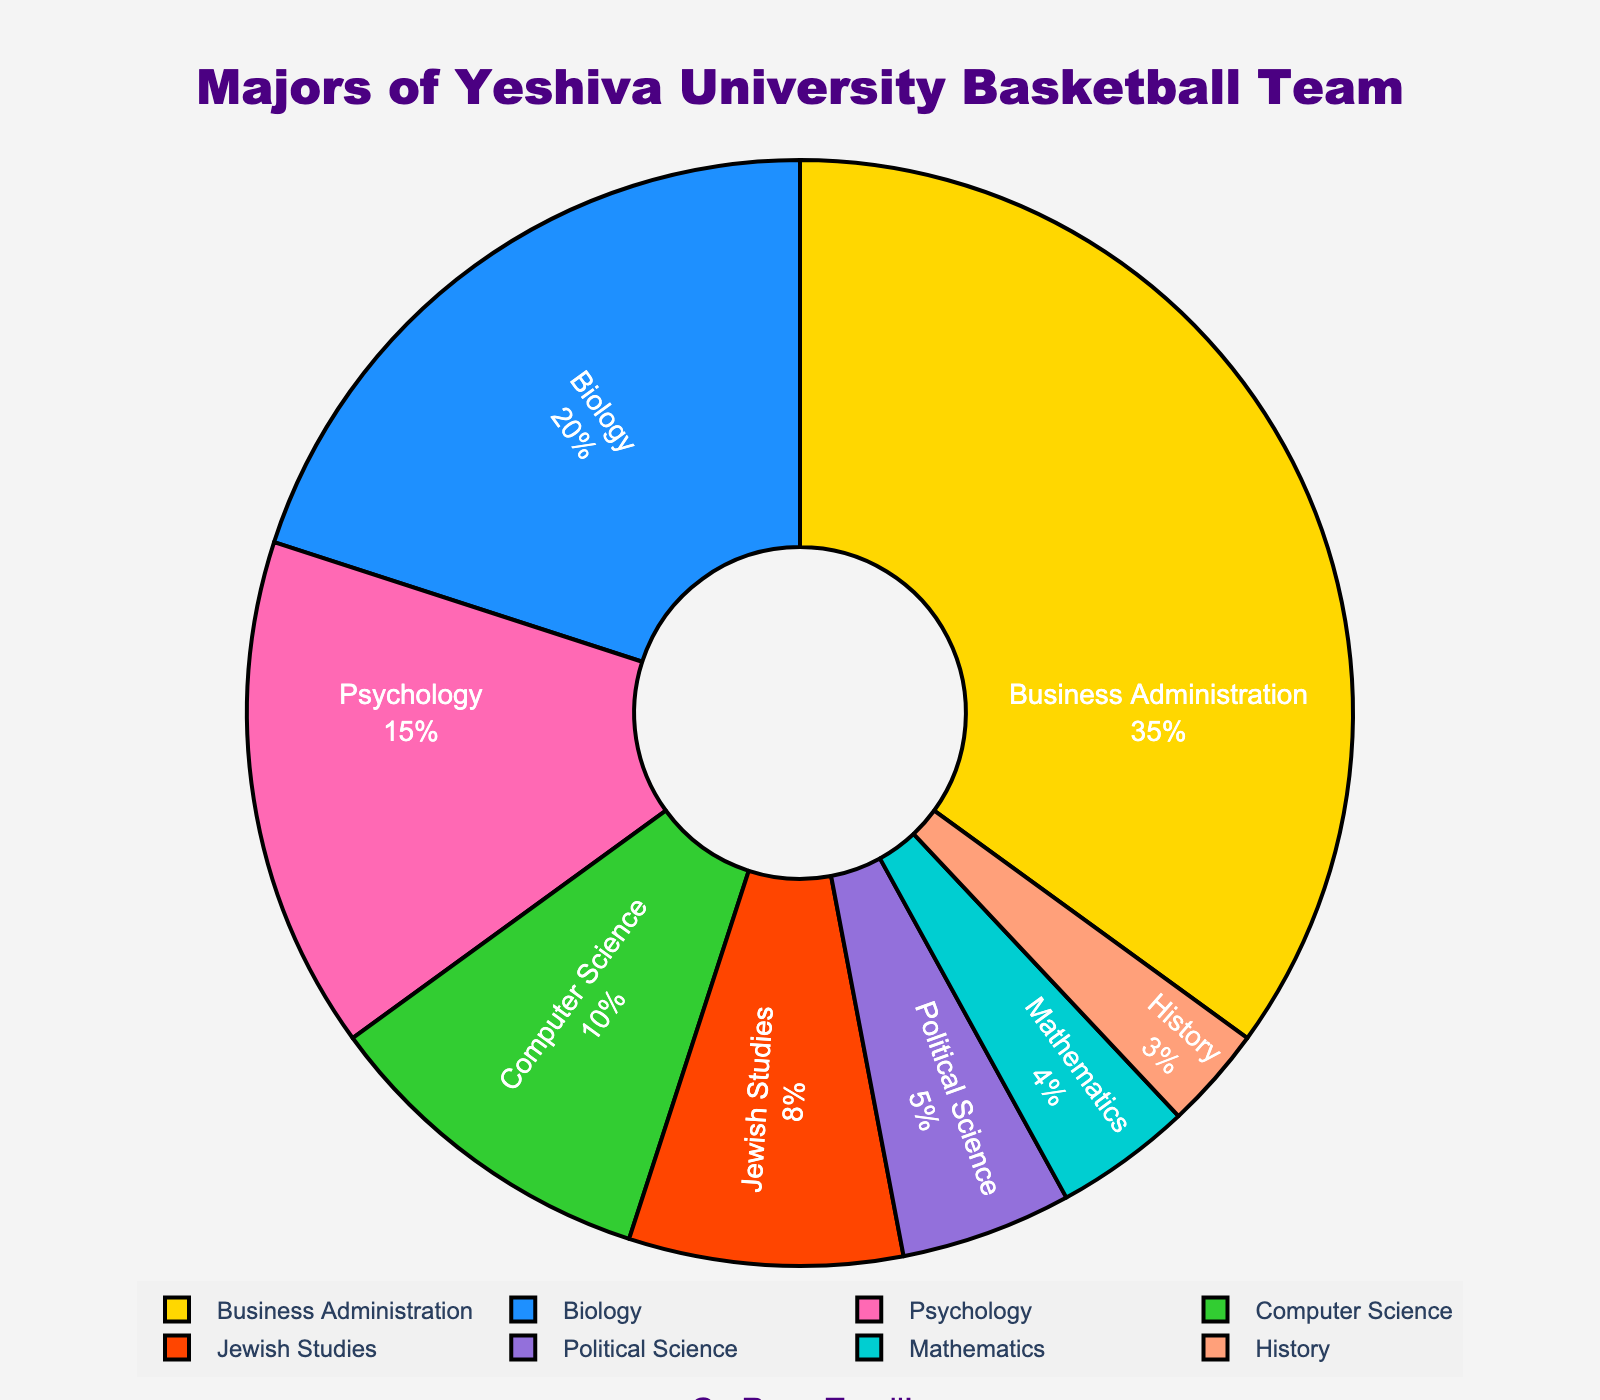what is the most popular major chosen by the basketball team members? The figure shows the percentage breakdown of each major. The major with the largest percentage is the most popular. In this case, it's Business Administration with 35%.
Answer: Business Administration What is the combined percentage of students majoring in Psychology and Political Science? To find the combined percentage, add the percentages for Psychology (15%) and Political Science (5%). 15 + 5 = 20.
Answer: 20% Which major has a lower percentage, Jewish Studies or Mathematics? The figure depicts Jewish Studies at 8% and Mathematics at 4%. By comparing these percentages, Mathematics has a lower percentage than Jewish Studies.
Answer: Mathematics What is the total percentage of students majoring in STEM fields (Biology, Computer Science, and Mathematics)? Add the percentages for Biology (20%), Computer Science (10%), and Mathematics (4%). The sum is 20 + 10 + 4 = 34.
Answer: 34% Estimate the difference in percentage between Business Administration and Biology majors. Subtract the percentage of Biology majors (20%) from Business Administration majors (35%). 35 - 20 = 15.
Answer: 15% Rank the top three majors by their percentage. The figure shows the percentages for all majors. The top three are Business Administration (35%), Biology (20%), and Psychology (15%) in descending order.
Answer: Business Administration, Biology, Psychology Are more students majoring in Computer Science or Jewish Studies? The figure shows Computer Science at 10% and Jewish Studies at 8%. Computer Science has a higher percentage than Jewish Studies.
Answer: Computer Science Which major accounts for the smallest percentage of students? According to the figure, the major with the smallest percentage is History at 3%.
Answer: History What percentage of the basketball team members is studying non-STEM majors? First, sum the percentages of non-STEM majors: Business Administration (35%), Psychology (15%), Jewish Studies (8%), Political Science (5%), and History (3%). The sum is 35 + 15 + 8 + 5 + 3 = 66.
Answer: 66% If you combine the percentages of Biology and Mathematics, how does it compare to the percentage of Business Administration? First, add the percentages of Biology (20%) and Mathematics (4%), which gives 24%. Compare this to Business Administration (35%). 24% < 35%, so the combined percentage of Biology and Mathematics is less.
Answer: Less 